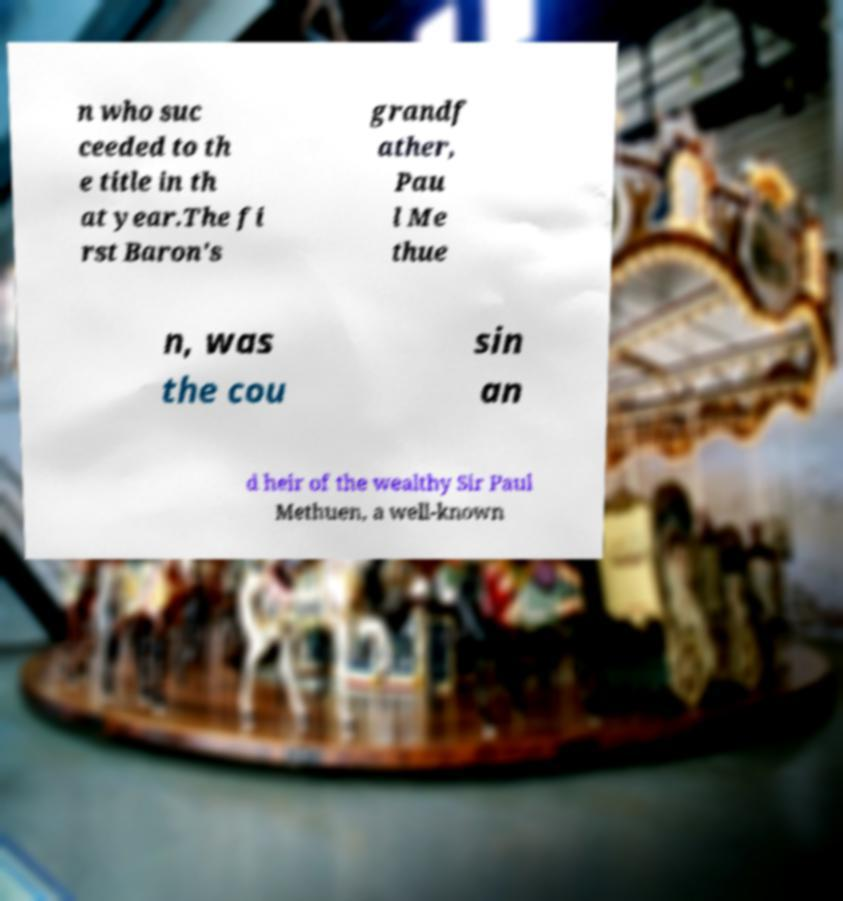For documentation purposes, I need the text within this image transcribed. Could you provide that? n who suc ceeded to th e title in th at year.The fi rst Baron's grandf ather, Pau l Me thue n, was the cou sin an d heir of the wealthy Sir Paul Methuen, a well-known 